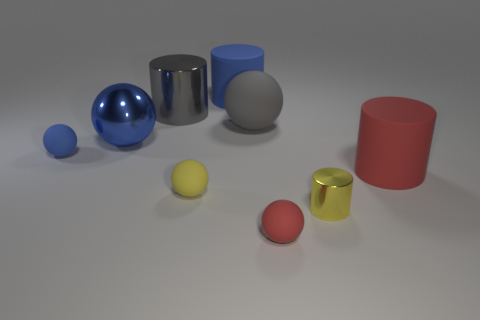Subtract all big blue rubber cylinders. How many cylinders are left? 3 Subtract all spheres. How many objects are left? 4 Subtract all blue cubes. How many blue spheres are left? 2 Add 1 large gray matte objects. How many objects exist? 10 Subtract all yellow cylinders. How many cylinders are left? 3 Subtract all small purple shiny cylinders. Subtract all tiny yellow shiny cylinders. How many objects are left? 8 Add 7 red objects. How many red objects are left? 9 Add 4 red balls. How many red balls exist? 5 Subtract 0 green cubes. How many objects are left? 9 Subtract 2 cylinders. How many cylinders are left? 2 